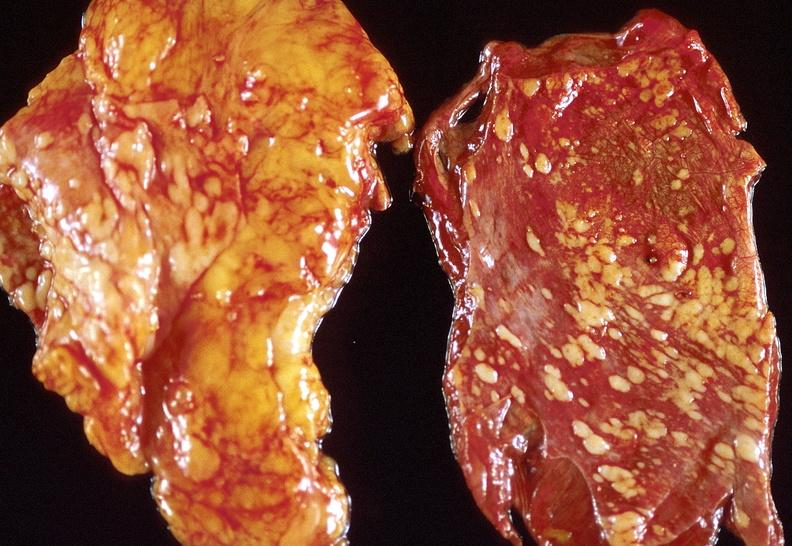what does this image show?
Answer the question using a single word or phrase. Lung carcinoma 